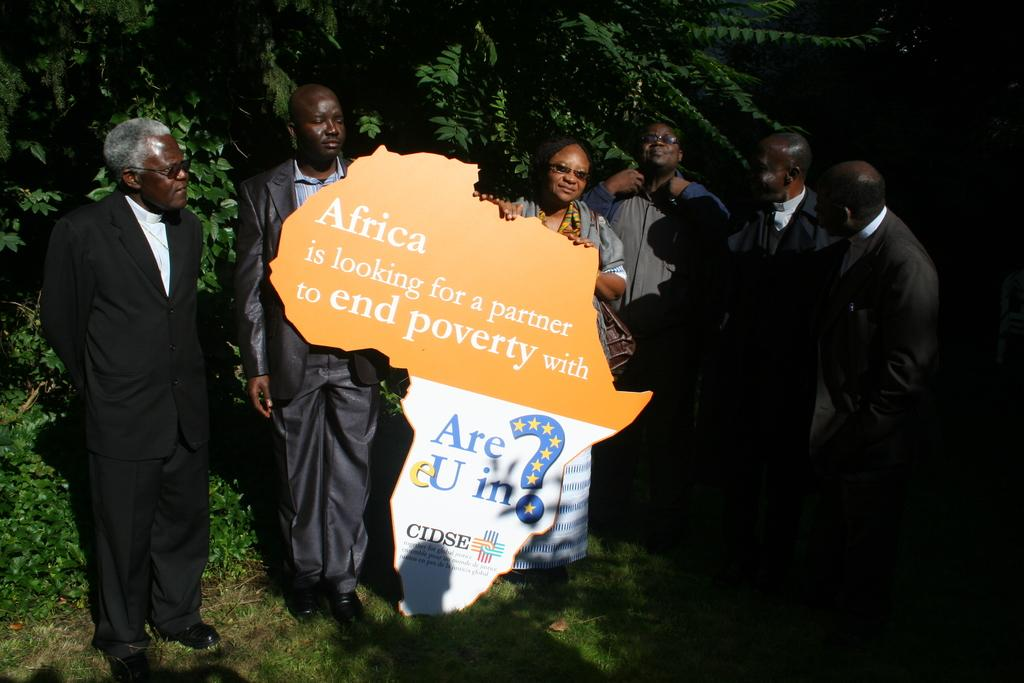Who or what can be seen in the image? There are people in the image. What is the cutout with text in the image used for? The cutout with text in the image is likely used for decoration or as a prop. What type of natural environment is visible in the background of the image? There are trees in the background of the image. What type of ground surface is visible at the bottom of the image? There is grass at the bottom of the image. What type of apparel is the self wearing in the image? There is no self present in the image, as the term "self" refers to one's own person, and the image features people other than the viewer. What notes or thoughts are written in the notebook in the image? There is no notebook present in the image, so it is not possible to answer that question. 